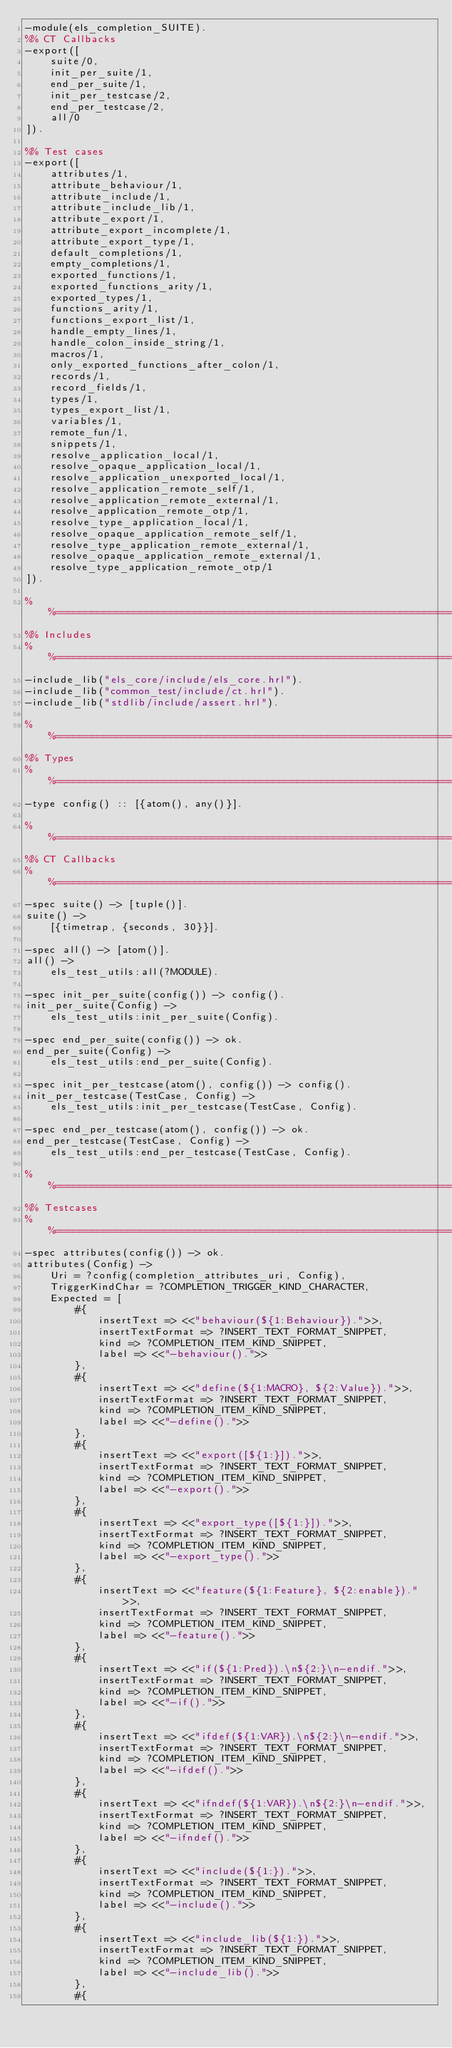<code> <loc_0><loc_0><loc_500><loc_500><_Erlang_>-module(els_completion_SUITE).
%% CT Callbacks
-export([
    suite/0,
    init_per_suite/1,
    end_per_suite/1,
    init_per_testcase/2,
    end_per_testcase/2,
    all/0
]).

%% Test cases
-export([
    attributes/1,
    attribute_behaviour/1,
    attribute_include/1,
    attribute_include_lib/1,
    attribute_export/1,
    attribute_export_incomplete/1,
    attribute_export_type/1,
    default_completions/1,
    empty_completions/1,
    exported_functions/1,
    exported_functions_arity/1,
    exported_types/1,
    functions_arity/1,
    functions_export_list/1,
    handle_empty_lines/1,
    handle_colon_inside_string/1,
    macros/1,
    only_exported_functions_after_colon/1,
    records/1,
    record_fields/1,
    types/1,
    types_export_list/1,
    variables/1,
    remote_fun/1,
    snippets/1,
    resolve_application_local/1,
    resolve_opaque_application_local/1,
    resolve_application_unexported_local/1,
    resolve_application_remote_self/1,
    resolve_application_remote_external/1,
    resolve_application_remote_otp/1,
    resolve_type_application_local/1,
    resolve_opaque_application_remote_self/1,
    resolve_type_application_remote_external/1,
    resolve_opaque_application_remote_external/1,
    resolve_type_application_remote_otp/1
]).

%%==============================================================================
%% Includes
%%==============================================================================
-include_lib("els_core/include/els_core.hrl").
-include_lib("common_test/include/ct.hrl").
-include_lib("stdlib/include/assert.hrl").

%%==============================================================================
%% Types
%%==============================================================================
-type config() :: [{atom(), any()}].

%%==============================================================================
%% CT Callbacks
%%==============================================================================
-spec suite() -> [tuple()].
suite() ->
    [{timetrap, {seconds, 30}}].

-spec all() -> [atom()].
all() ->
    els_test_utils:all(?MODULE).

-spec init_per_suite(config()) -> config().
init_per_suite(Config) ->
    els_test_utils:init_per_suite(Config).

-spec end_per_suite(config()) -> ok.
end_per_suite(Config) ->
    els_test_utils:end_per_suite(Config).

-spec init_per_testcase(atom(), config()) -> config().
init_per_testcase(TestCase, Config) ->
    els_test_utils:init_per_testcase(TestCase, Config).

-spec end_per_testcase(atom(), config()) -> ok.
end_per_testcase(TestCase, Config) ->
    els_test_utils:end_per_testcase(TestCase, Config).

%%==============================================================================
%% Testcases
%%==============================================================================
-spec attributes(config()) -> ok.
attributes(Config) ->
    Uri = ?config(completion_attributes_uri, Config),
    TriggerKindChar = ?COMPLETION_TRIGGER_KIND_CHARACTER,
    Expected = [
        #{
            insertText => <<"behaviour(${1:Behaviour}).">>,
            insertTextFormat => ?INSERT_TEXT_FORMAT_SNIPPET,
            kind => ?COMPLETION_ITEM_KIND_SNIPPET,
            label => <<"-behaviour().">>
        },
        #{
            insertText => <<"define(${1:MACRO}, ${2:Value}).">>,
            insertTextFormat => ?INSERT_TEXT_FORMAT_SNIPPET,
            kind => ?COMPLETION_ITEM_KIND_SNIPPET,
            label => <<"-define().">>
        },
        #{
            insertText => <<"export([${1:}]).">>,
            insertTextFormat => ?INSERT_TEXT_FORMAT_SNIPPET,
            kind => ?COMPLETION_ITEM_KIND_SNIPPET,
            label => <<"-export().">>
        },
        #{
            insertText => <<"export_type([${1:}]).">>,
            insertTextFormat => ?INSERT_TEXT_FORMAT_SNIPPET,
            kind => ?COMPLETION_ITEM_KIND_SNIPPET,
            label => <<"-export_type().">>
        },
        #{
            insertText => <<"feature(${1:Feature}, ${2:enable}).">>,
            insertTextFormat => ?INSERT_TEXT_FORMAT_SNIPPET,
            kind => ?COMPLETION_ITEM_KIND_SNIPPET,
            label => <<"-feature().">>
        },
        #{
            insertText => <<"if(${1:Pred}).\n${2:}\n-endif.">>,
            insertTextFormat => ?INSERT_TEXT_FORMAT_SNIPPET,
            kind => ?COMPLETION_ITEM_KIND_SNIPPET,
            label => <<"-if().">>
        },
        #{
            insertText => <<"ifdef(${1:VAR}).\n${2:}\n-endif.">>,
            insertTextFormat => ?INSERT_TEXT_FORMAT_SNIPPET,
            kind => ?COMPLETION_ITEM_KIND_SNIPPET,
            label => <<"-ifdef().">>
        },
        #{
            insertText => <<"ifndef(${1:VAR}).\n${2:}\n-endif.">>,
            insertTextFormat => ?INSERT_TEXT_FORMAT_SNIPPET,
            kind => ?COMPLETION_ITEM_KIND_SNIPPET,
            label => <<"-ifndef().">>
        },
        #{
            insertText => <<"include(${1:}).">>,
            insertTextFormat => ?INSERT_TEXT_FORMAT_SNIPPET,
            kind => ?COMPLETION_ITEM_KIND_SNIPPET,
            label => <<"-include().">>
        },
        #{
            insertText => <<"include_lib(${1:}).">>,
            insertTextFormat => ?INSERT_TEXT_FORMAT_SNIPPET,
            kind => ?COMPLETION_ITEM_KIND_SNIPPET,
            label => <<"-include_lib().">>
        },
        #{</code> 